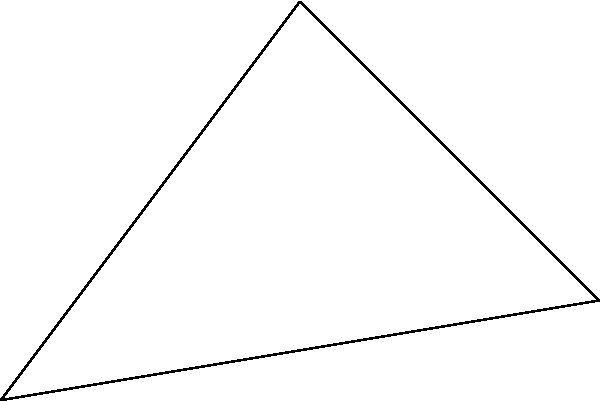In the starry opening scene, three celestial bodies form a triangle: the Time Warp Galaxy (A), the Transylvania Nebula (B), and Frankenstein's Star (C). If the distance between A and B is 5 light-years, and the angle at B is 90°, what is the non-Euclidean distance between A and C in light-years, assuming a curvature factor of 1.2? Let's approach this step-by-step, you creatures of the night!

1) In Euclidean geometry, we'd use the Pythagorean theorem. But this is Rocky Horror, darling, so we're going non-Euclidean!

2) First, let's calculate the Euclidean distance AC:
   $AC^2 = AB^2 + BC^2$ (Pythagorean theorem)
   $AC^2 = 5^2 + 5^2 = 50$
   $AC = \sqrt{50} = 5\sqrt{2} \approx 7.07$ light-years

3) Now, for the non-Euclidean distance, we'll use the curvature factor. The formula is:
   $d_{non-Euclidean} = \frac{\sinh(k \cdot d_{Euclidean})}{k}$
   Where $k$ is the curvature factor (1.2 in this case)

4) Plugging in our values:
   $d_{non-Euclidean} = \frac{\sinh(1.2 \cdot 5\sqrt{2})}{1.2}$

5) Let's calculate this step-by-step:
   $1.2 \cdot 5\sqrt{2} \approx 8.48$
   $\sinh(8.48) \approx 2406.81$
   $2406.81 / 1.2 \approx 2005.68$

6) Therefore, the non-Euclidean distance is approximately 2005.68 light-years.

Remember, in the world of Rocky Horror, it's not just a jump to the left, but a leap into non-Euclidean space!
Answer: 2005.68 light-years 